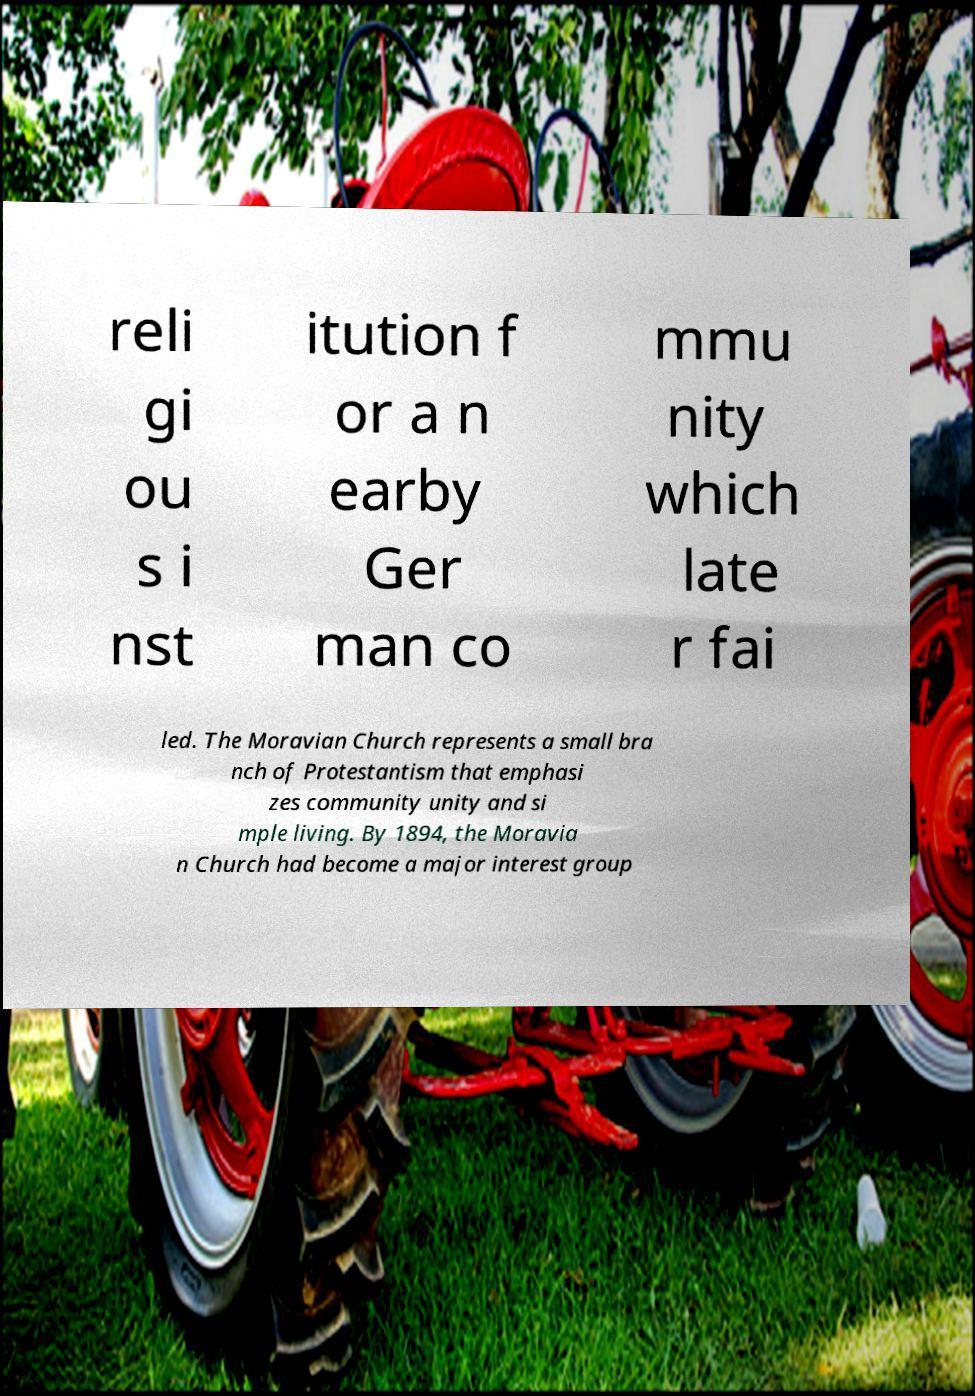I need the written content from this picture converted into text. Can you do that? reli gi ou s i nst itution f or a n earby Ger man co mmu nity which late r fai led. The Moravian Church represents a small bra nch of Protestantism that emphasi zes community unity and si mple living. By 1894, the Moravia n Church had become a major interest group 